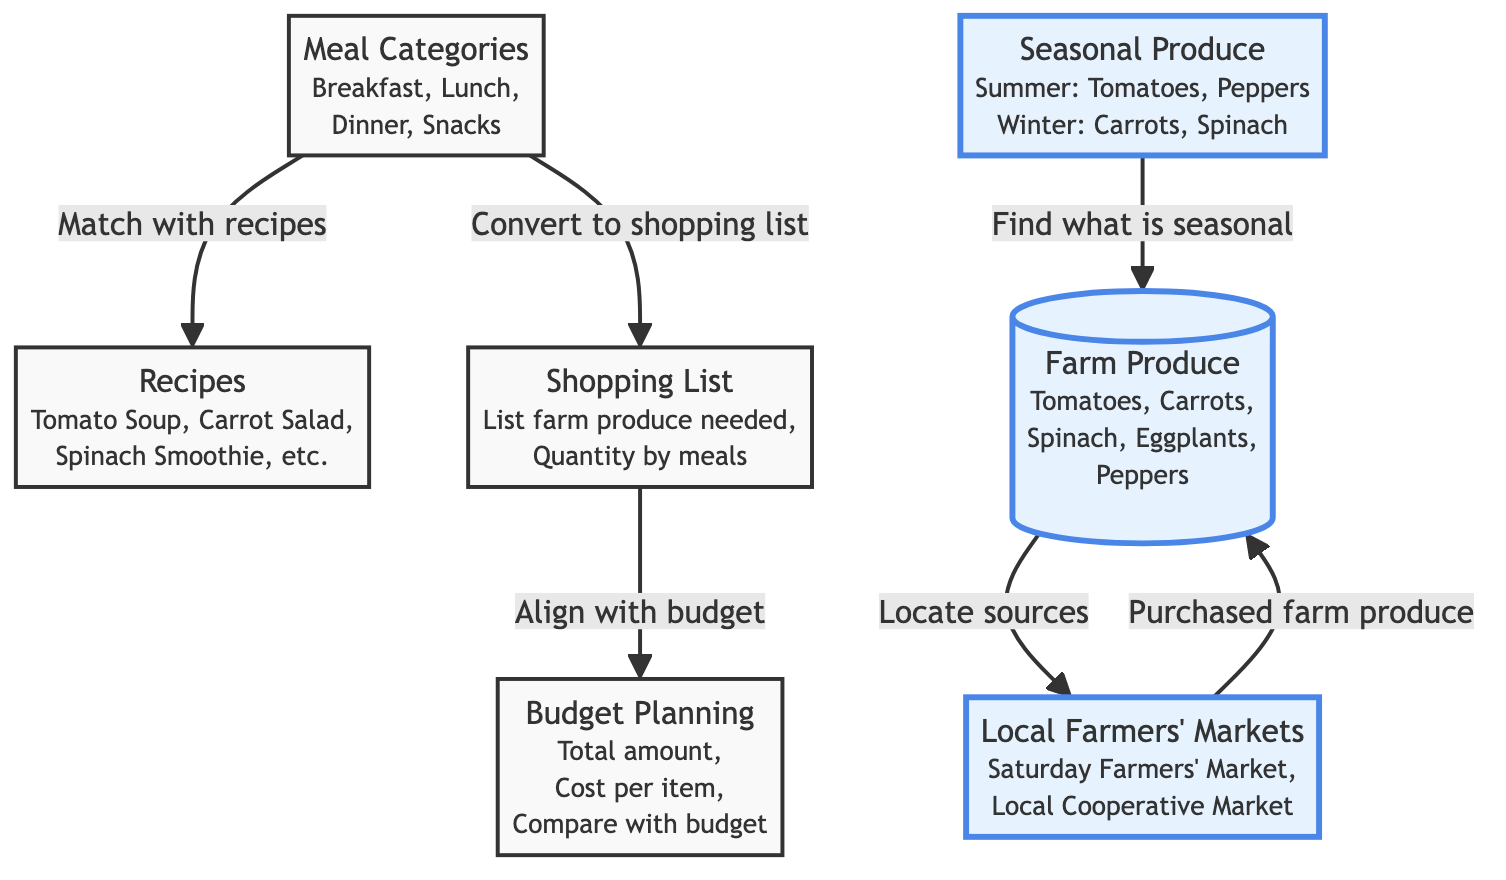What are the meal categories mentioned in the diagram? The diagram specifies that the meal categories are Breakfast, Lunch, Dinner, and Snacks. This information is directly listed under the node for Meal Categories.
Answer: Breakfast, Lunch, Dinner, Snacks How many types of farm produce are listed in the diagram? The node labeled "Farm Produce" mentions five items: Tomatoes, Carrots, Spinach, Eggplants, and Peppers. Thus, there are a total of five types of farm produce represented in the diagram.
Answer: 5 Which meal category is directly linked to recipes? The Meal Categories node is connected to Recipes, indicating that the meal categories are used to match with recipes in the diagram flow.
Answer: Recipes What is the main purpose of the Shopping List node? The Shopping List is described as a place to list farm produce needed and their quantity by meals, showing its function in the planning process. This is a direct description from the node.
Answer: List farm produce needed, Quantity by meals What seasonal produce is highlighted in the diagram for winter? The Seasonal Produce node specifies that Carrots and Spinach are applicable during the winter season, allowing us to identify these items as winter produce.
Answer: Carrots, Spinach How does the diagram suggest budgeting is aligned with shopping? The flow indicates that the Shopping List connects to Budget Planning, meaning that the quantity of food purchased should be compared against the final budget. This relationship highlights the importance of budgeting in regulating food purchases.
Answer: Align with budget What external sources of farm produce are mentioned in the diagram? The node for Local Farmers' Markets describes specific sources, namely "Saturday Farmers' Market" and "Local Cooperative Market," confirming these as the external sources for farm produce.
Answer: Saturday Farmers' Market, Local Cooperative Market How many nodes are focused on farm produce? There are three nodes specifically focused on farm produce: the Farm Produce node, the Seasonal Produce node, and the Local Farmers' Markets node. Therefore, the total number of nodes addressing farm produce directly is three.
Answer: 3 What is the relationship between the Shopping List and Budget Planning? According to the flow in the diagram, the Shopping List node connects directly to Budget Planning. This indicates that after creating a shopping list, efforts must be made to align those expenses with the overall budget.
Answer: Align with budget 